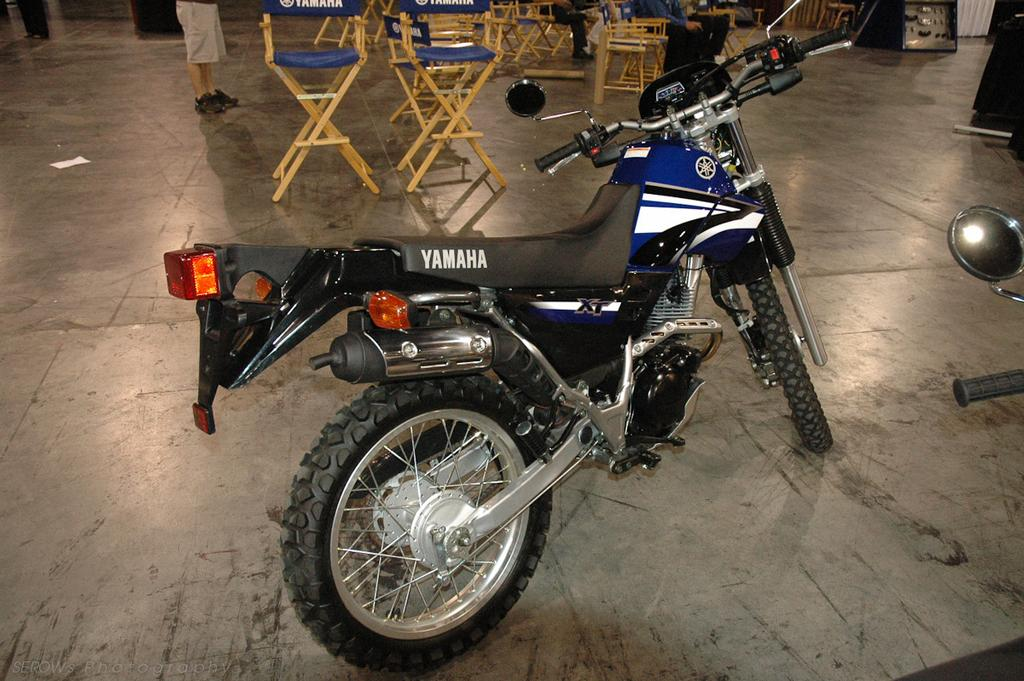What is the main subject of the picture? The main subject of the picture is a motorbike. What else can be seen in the picture besides the motorbike? There are chairs and a person standing in the picture. Can you describe the person in the picture? The person is standing, but their specific actions or appearance cannot be determined from the provided facts. What is visible in the background of the picture? There are additional objects in the background of the picture, but their specific nature cannot be determined from the provided facts. What type of soap is the person using to wash the motorbike in the image? There is no soap or washing activity present in the image; it only shows a motorbike, chairs, and a person standing. Is the queen present in the image? There is no mention of a queen or any royal figure in the provided facts, so it cannot be determined if the queen is present in the image. 